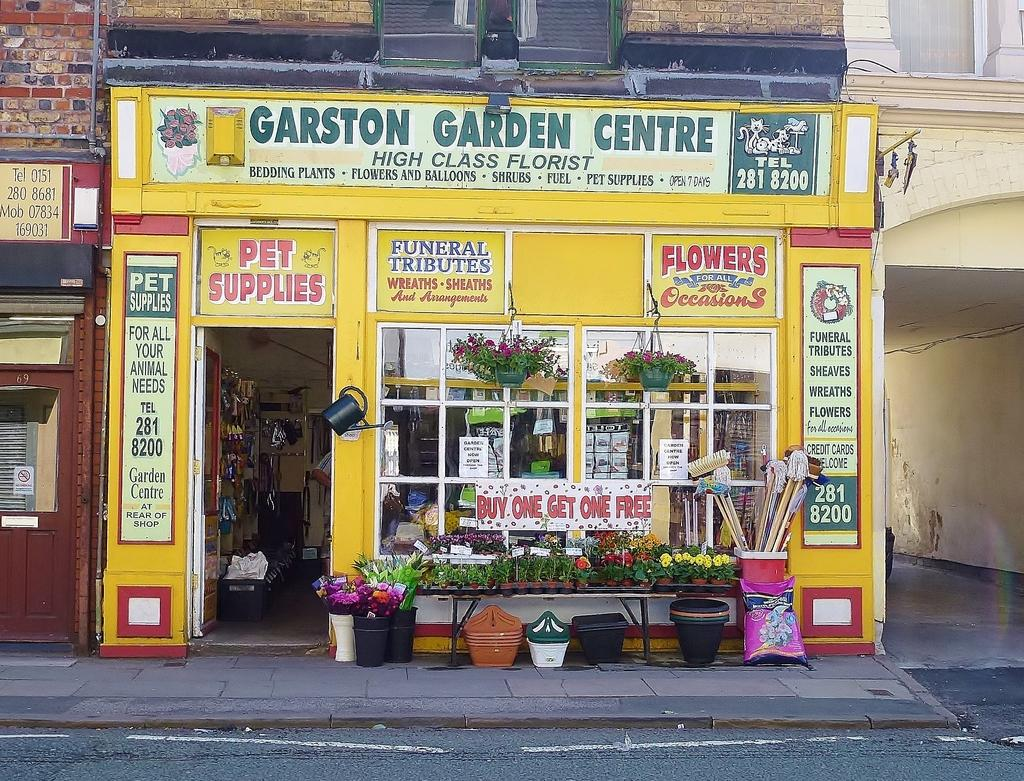What type of structures can be seen in the image? There are buildings in the image. Can you identify any specific type of building among them? Yes, there is a shop among the buildings. What distinguishes the shop from the other buildings? The shop has banners associated with it. Are there any plants visible in the image? Yes, there are potted plants in the image. What other objects can be seen in the image? There are additional objects visible in the image, but their specific nature is not mentioned in the provided facts. What type of tax is being discussed on the banners in the image? There is no mention of any tax on the banners in the image; they are simply associated with the shop. 